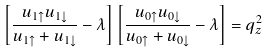Convert formula to latex. <formula><loc_0><loc_0><loc_500><loc_500>\left [ \frac { u _ { 1 \uparrow } u _ { 1 \downarrow } } { u _ { 1 \uparrow } + u _ { 1 \downarrow } } - \lambda \right ] \left [ \frac { u _ { 0 \uparrow } u _ { 0 \downarrow } } { u _ { 0 \uparrow } + u _ { 0 \downarrow } } - \lambda \right ] = q _ { z } ^ { 2 } \,</formula> 